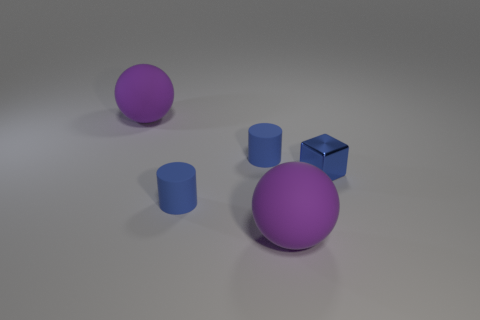There is a blue object behind the blue cube; does it have the same size as the cube?
Offer a very short reply. Yes. Is the number of tiny cylinders in front of the blue shiny thing greater than the number of big yellow metallic objects?
Your answer should be compact. Yes. Are there any tiny blue rubber objects on the right side of the tiny blue metallic block?
Your answer should be compact. No. Is there a cylinder of the same size as the metal object?
Give a very brief answer. Yes. What is the block made of?
Provide a short and direct response. Metal. There is a small metallic thing; what shape is it?
Keep it short and to the point. Cube. What number of objects are the same color as the metal block?
Make the answer very short. 2. What is the purple thing to the right of the purple matte ball that is behind the blue thing that is in front of the tiny blue metallic thing made of?
Make the answer very short. Rubber. How many blue things are small matte objects or balls?
Offer a terse response. 2. What is the size of the sphere that is behind the small matte object left of the small blue rubber cylinder behind the tiny shiny thing?
Offer a very short reply. Large. 